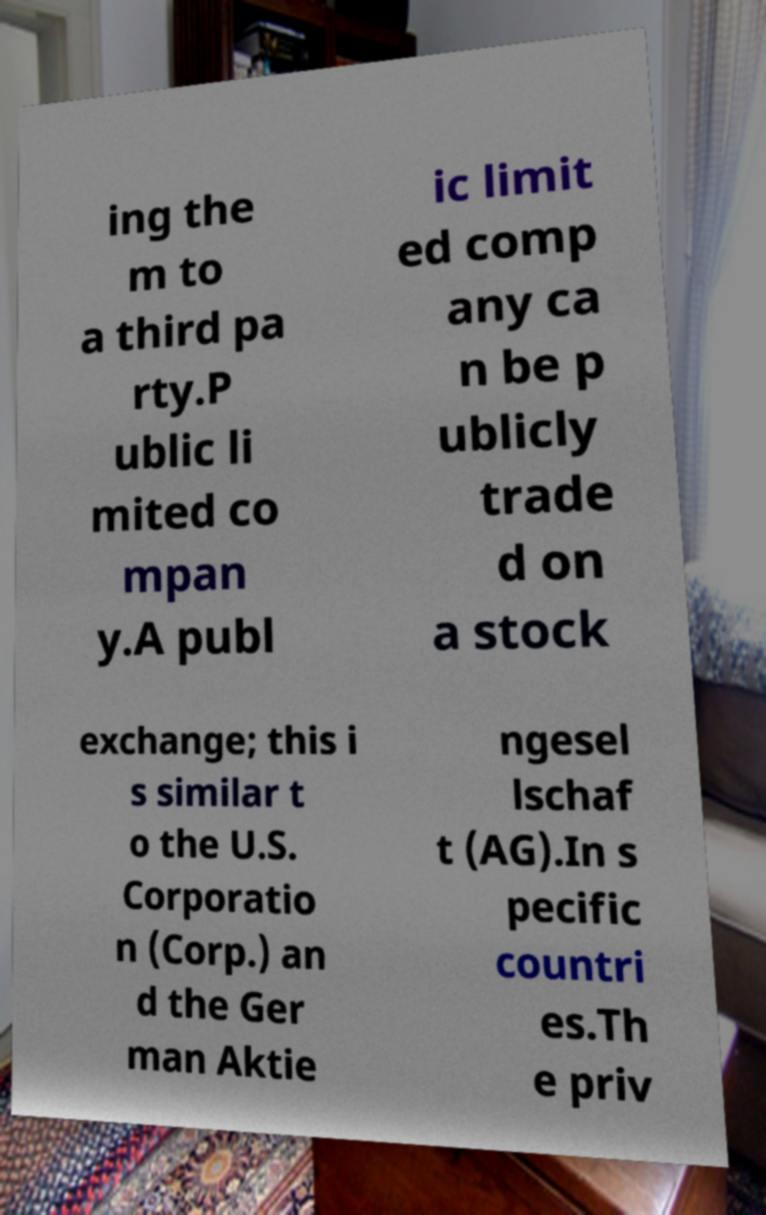There's text embedded in this image that I need extracted. Can you transcribe it verbatim? ing the m to a third pa rty.P ublic li mited co mpan y.A publ ic limit ed comp any ca n be p ublicly trade d on a stock exchange; this i s similar t o the U.S. Corporatio n (Corp.) an d the Ger man Aktie ngesel lschaf t (AG).In s pecific countri es.Th e priv 